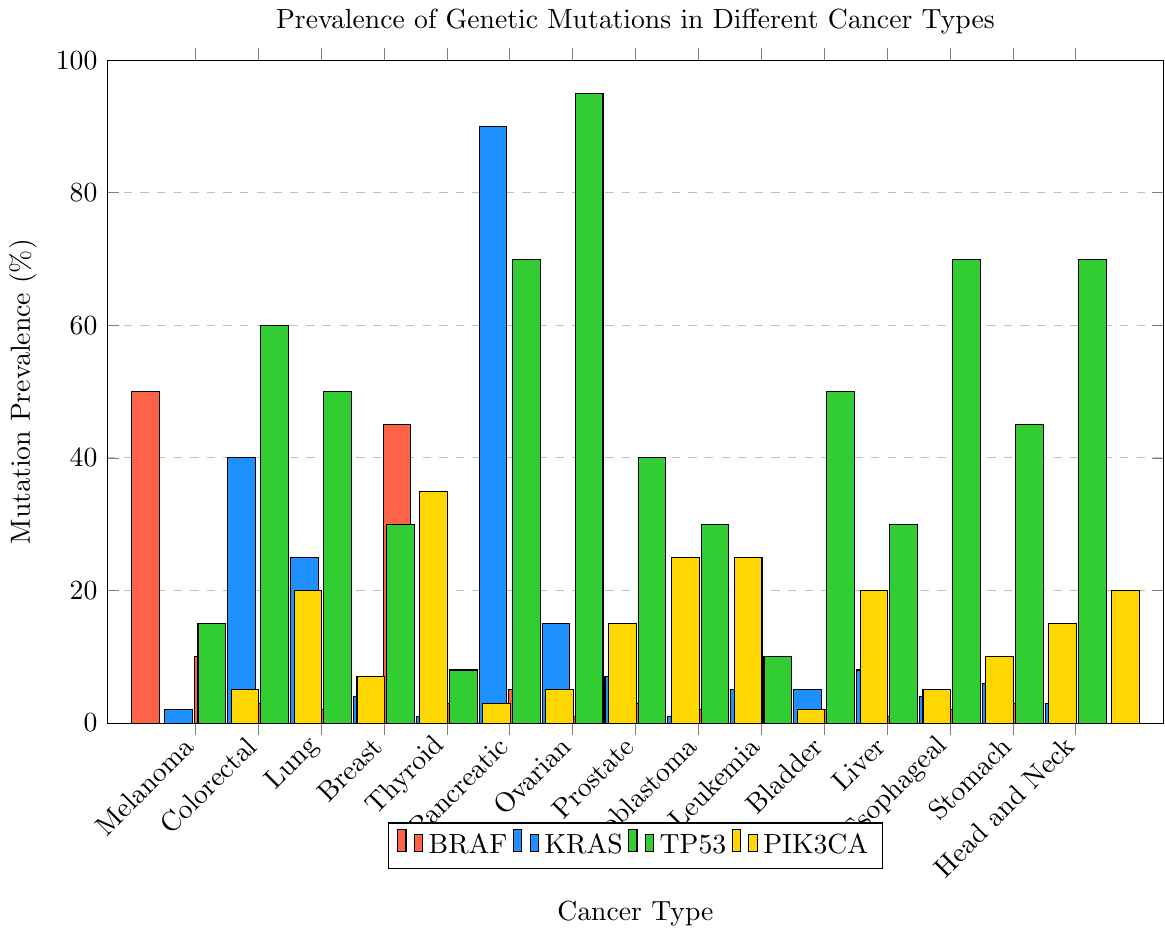What's the most prevalent mutation in Colorectal Cancer? The highest bar for Colorectal Cancer corresponds to TP53 Mutation, which has a prevalence of 60%.
Answer: TP53 Mutation Which cancer type shows the highest prevalence for KRAS Mutation? Pancreatic Cancer has the highest bar for KRAS Mutation, showing a prevalence value of 90%, which is higher than any other cancer type for this mutation.
Answer: Pancreatic Cancer In which cancer type is PIK3CA Mutation more prevalent than BRAF Mutation? For Breast Cancer, the PIK3CA Mutation has a prevalence of 35%, which is higher than the BRAF Mutation prevalence of 2%.
Answer: Breast Cancer What's the combined prevalence of TP53 and KRAS Mutations in Lung Cancer? The prevalence of TP53 Mutation in Lung Cancer is 50%, and the prevalence of KRAS Mutation is 25%. Adding these values gives 50 + 25 = 75%.
Answer: 75% Which cancer type has the lowest prevalence of PIK3CA Mutation? Leukemia shows the lowest bar for PIK3CA Mutation, with a prevalence of 2%.
Answer: Leukemia Compare the prevalence of TP53 Mutation in Ovarian Cancer and Esophageal Cancer. Which one is higher and by how much? The prevalence of TP53 Mutation in Ovarian Cancer is 95%, while in Esophageal Cancer, it is 70%. The difference is 95 - 70 = 25%.
Answer: Ovarian Cancer by 25% Does any cancer type have an equal prevalence of BRAF and KRAS Mutations? No cancer type has bars of equal height for both BRAF and KRAS Mutations; they are all different.
Answer: No Among Melanoma, Breast Cancer, and Thyroid Cancer, which has the highest prevalence of TP53 Mutation? By comparing the bars for TP53 Mutation among Melanoma (15%), Breast Cancer (30%), and Thyroid Cancer (8%), Breast Cancer has the highest bar.
Answer: Breast Cancer 